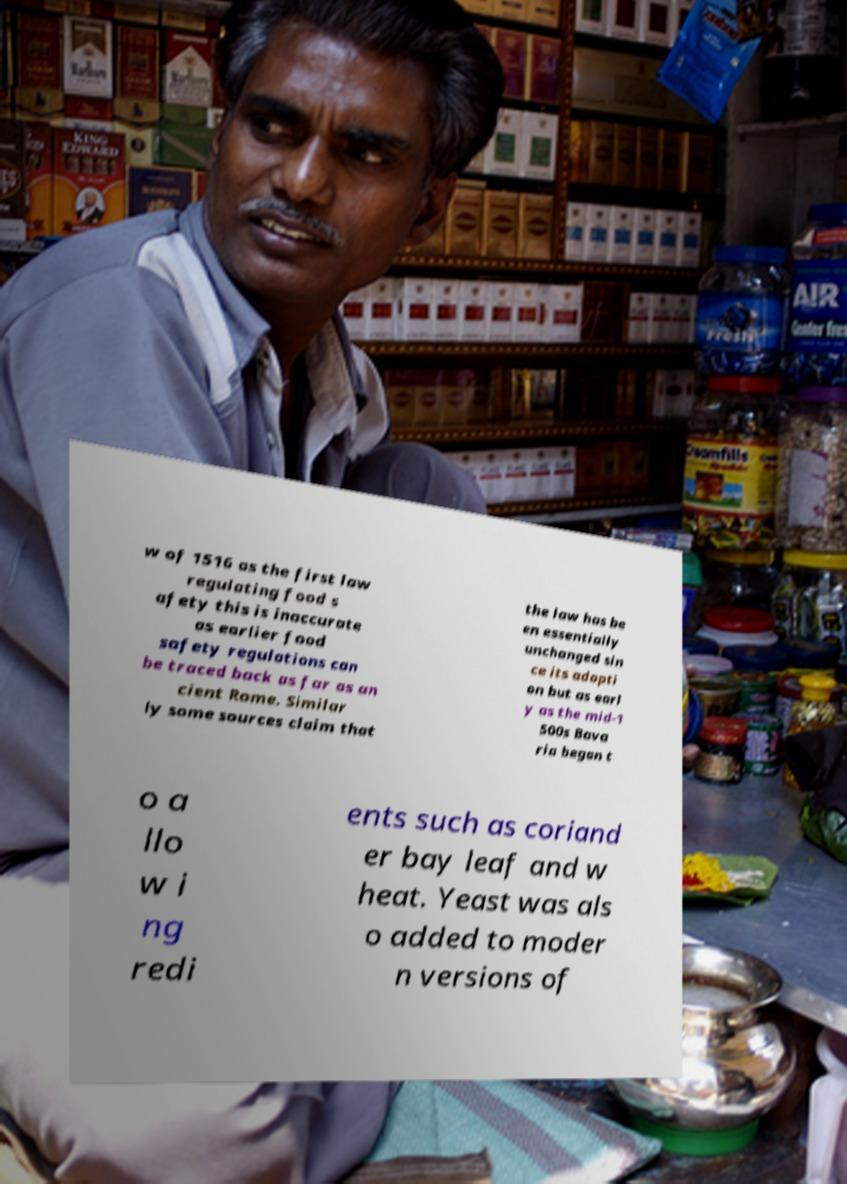I need the written content from this picture converted into text. Can you do that? w of 1516 as the first law regulating food s afety this is inaccurate as earlier food safety regulations can be traced back as far as an cient Rome. Similar ly some sources claim that the law has be en essentially unchanged sin ce its adopti on but as earl y as the mid-1 500s Bava ria began t o a llo w i ng redi ents such as coriand er bay leaf and w heat. Yeast was als o added to moder n versions of 